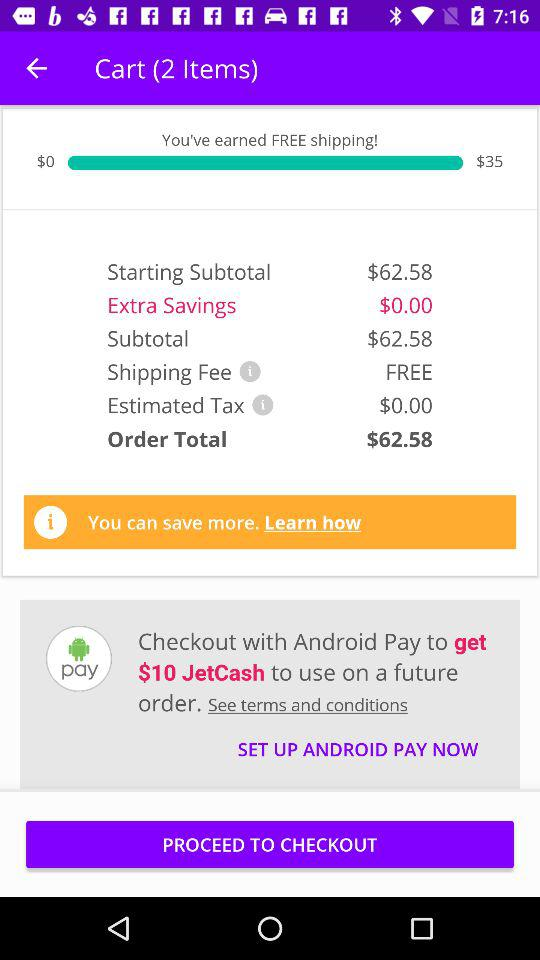What is the estimated tax? The estimated tax is $0.00. 